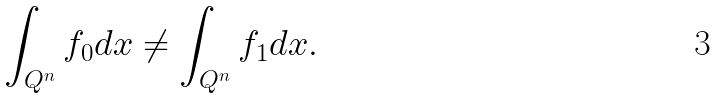Convert formula to latex. <formula><loc_0><loc_0><loc_500><loc_500>\int _ { Q ^ { n } } f _ { 0 } d x \not = \int _ { Q ^ { n } } f _ { 1 } d x .</formula> 